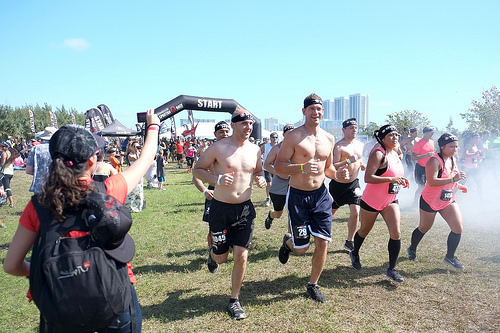<image>
Is the runner behind the runner? Yes. From this viewpoint, the runner is positioned behind the runner, with the runner partially or fully occluding the runner. 